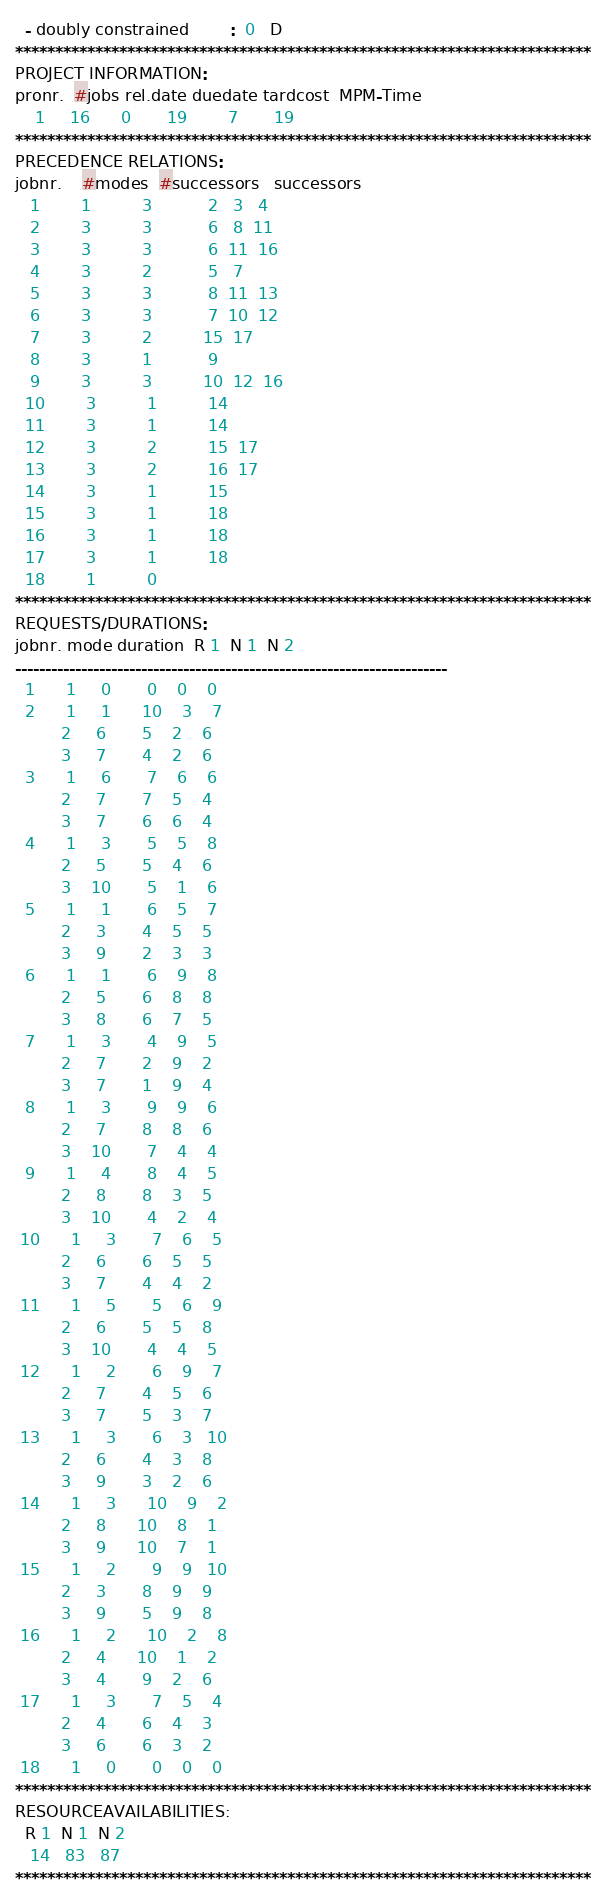<code> <loc_0><loc_0><loc_500><loc_500><_ObjectiveC_>  - doubly constrained        :  0   D
************************************************************************
PROJECT INFORMATION:
pronr.  #jobs rel.date duedate tardcost  MPM-Time
    1     16      0       19        7       19
************************************************************************
PRECEDENCE RELATIONS:
jobnr.    #modes  #successors   successors
   1        1          3           2   3   4
   2        3          3           6   8  11
   3        3          3           6  11  16
   4        3          2           5   7
   5        3          3           8  11  13
   6        3          3           7  10  12
   7        3          2          15  17
   8        3          1           9
   9        3          3          10  12  16
  10        3          1          14
  11        3          1          14
  12        3          2          15  17
  13        3          2          16  17
  14        3          1          15
  15        3          1          18
  16        3          1          18
  17        3          1          18
  18        1          0        
************************************************************************
REQUESTS/DURATIONS:
jobnr. mode duration  R 1  N 1  N 2
------------------------------------------------------------------------
  1      1     0       0    0    0
  2      1     1      10    3    7
         2     6       5    2    6
         3     7       4    2    6
  3      1     6       7    6    6
         2     7       7    5    4
         3     7       6    6    4
  4      1     3       5    5    8
         2     5       5    4    6
         3    10       5    1    6
  5      1     1       6    5    7
         2     3       4    5    5
         3     9       2    3    3
  6      1     1       6    9    8
         2     5       6    8    8
         3     8       6    7    5
  7      1     3       4    9    5
         2     7       2    9    2
         3     7       1    9    4
  8      1     3       9    9    6
         2     7       8    8    6
         3    10       7    4    4
  9      1     4       8    4    5
         2     8       8    3    5
         3    10       4    2    4
 10      1     3       7    6    5
         2     6       6    5    5
         3     7       4    4    2
 11      1     5       5    6    9
         2     6       5    5    8
         3    10       4    4    5
 12      1     2       6    9    7
         2     7       4    5    6
         3     7       5    3    7
 13      1     3       6    3   10
         2     6       4    3    8
         3     9       3    2    6
 14      1     3      10    9    2
         2     8      10    8    1
         3     9      10    7    1
 15      1     2       9    9   10
         2     3       8    9    9
         3     9       5    9    8
 16      1     2      10    2    8
         2     4      10    1    2
         3     4       9    2    6
 17      1     3       7    5    4
         2     4       6    4    3
         3     6       6    3    2
 18      1     0       0    0    0
************************************************************************
RESOURCEAVAILABILITIES:
  R 1  N 1  N 2
   14   83   87
************************************************************************
</code> 